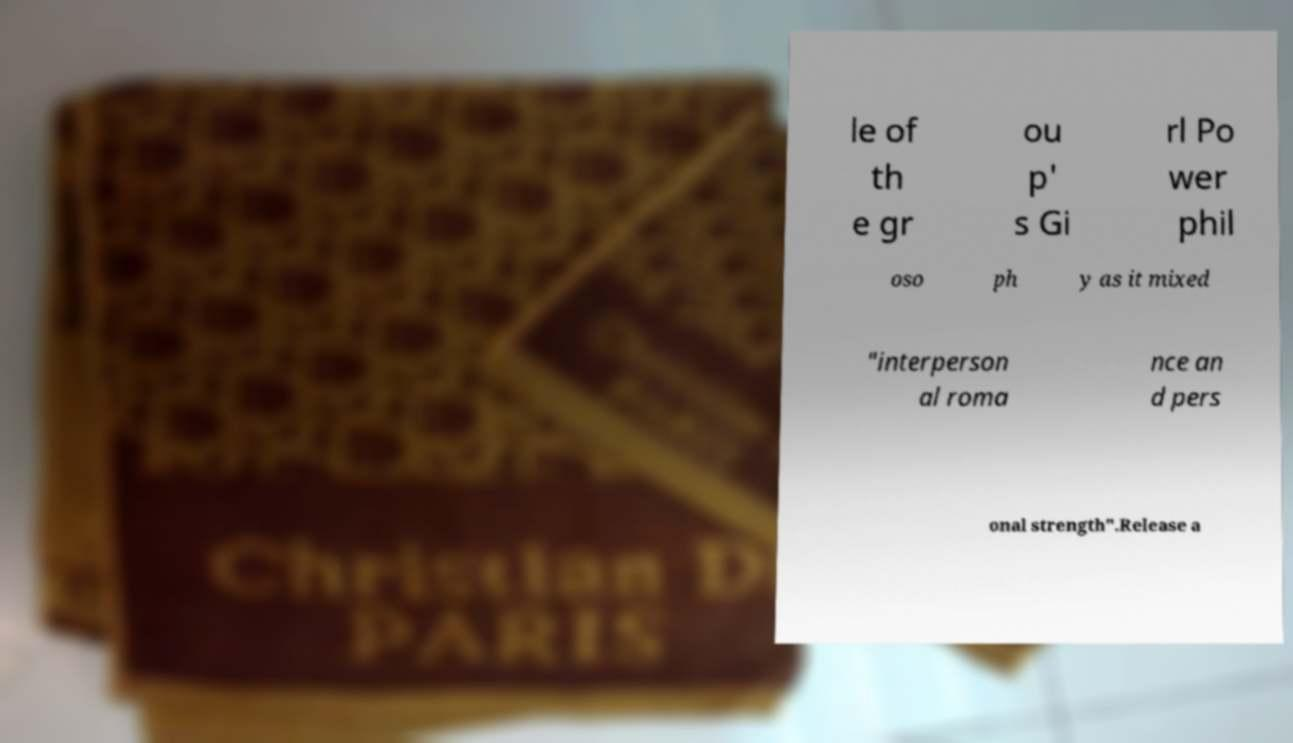For documentation purposes, I need the text within this image transcribed. Could you provide that? le of th e gr ou p' s Gi rl Po wer phil oso ph y as it mixed "interperson al roma nce an d pers onal strength".Release a 